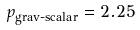Convert formula to latex. <formula><loc_0><loc_0><loc_500><loc_500>p _ { \text {grav-scalar} } = 2 . 2 5</formula> 